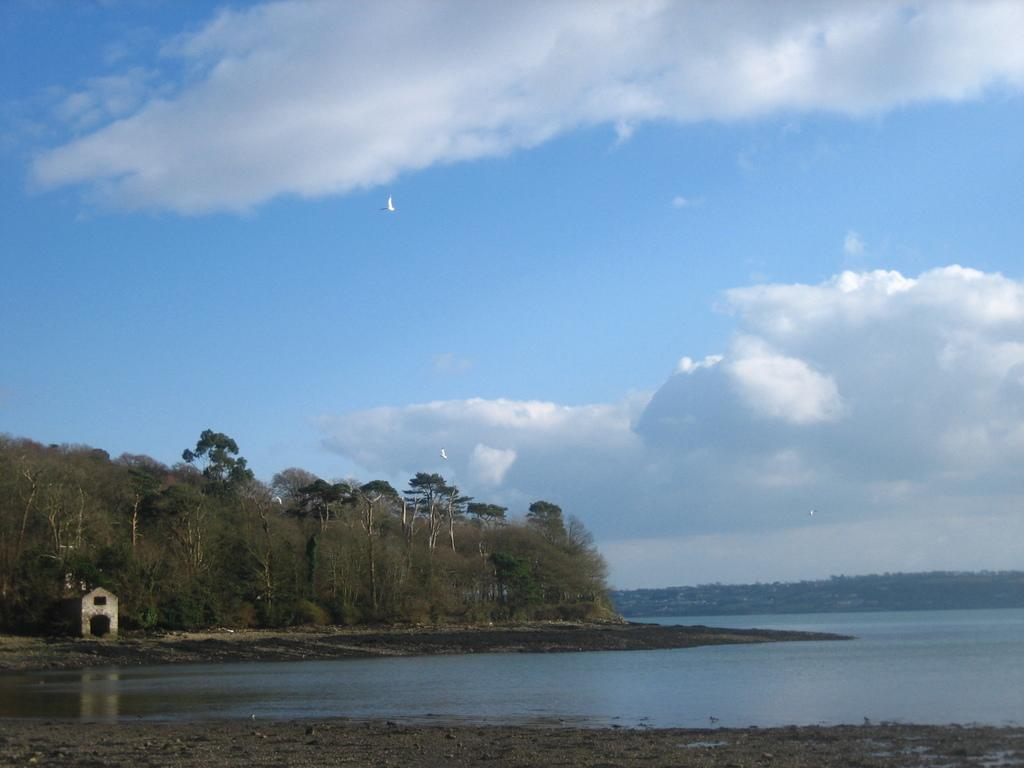What type of natural vegetation is present in the image? There are trees in the image. What type of structure can be seen near the water in the image? There is a house on the sea shore in the image. What geographical feature is visible in the background of the image? There are mountains visible in the image. What is the condition of the sky in the image? The sky is clouded in the image. What type of committee is meeting in the image? There is no committee meeting in the image; it features trees, a house on the sea shore, mountains, and a clouded sky. What type of paper is being used by the trees in the image? There is no paper present in the image; it features trees, a house on the sea shore, mountains, and a clouded sky. 